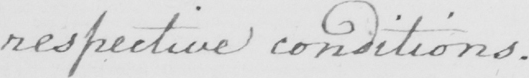Please provide the text content of this handwritten line. respective conditions . 